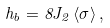<formula> <loc_0><loc_0><loc_500><loc_500>h _ { b } = 8 J _ { 2 } \, \langle \sigma \rangle \, ,</formula> 